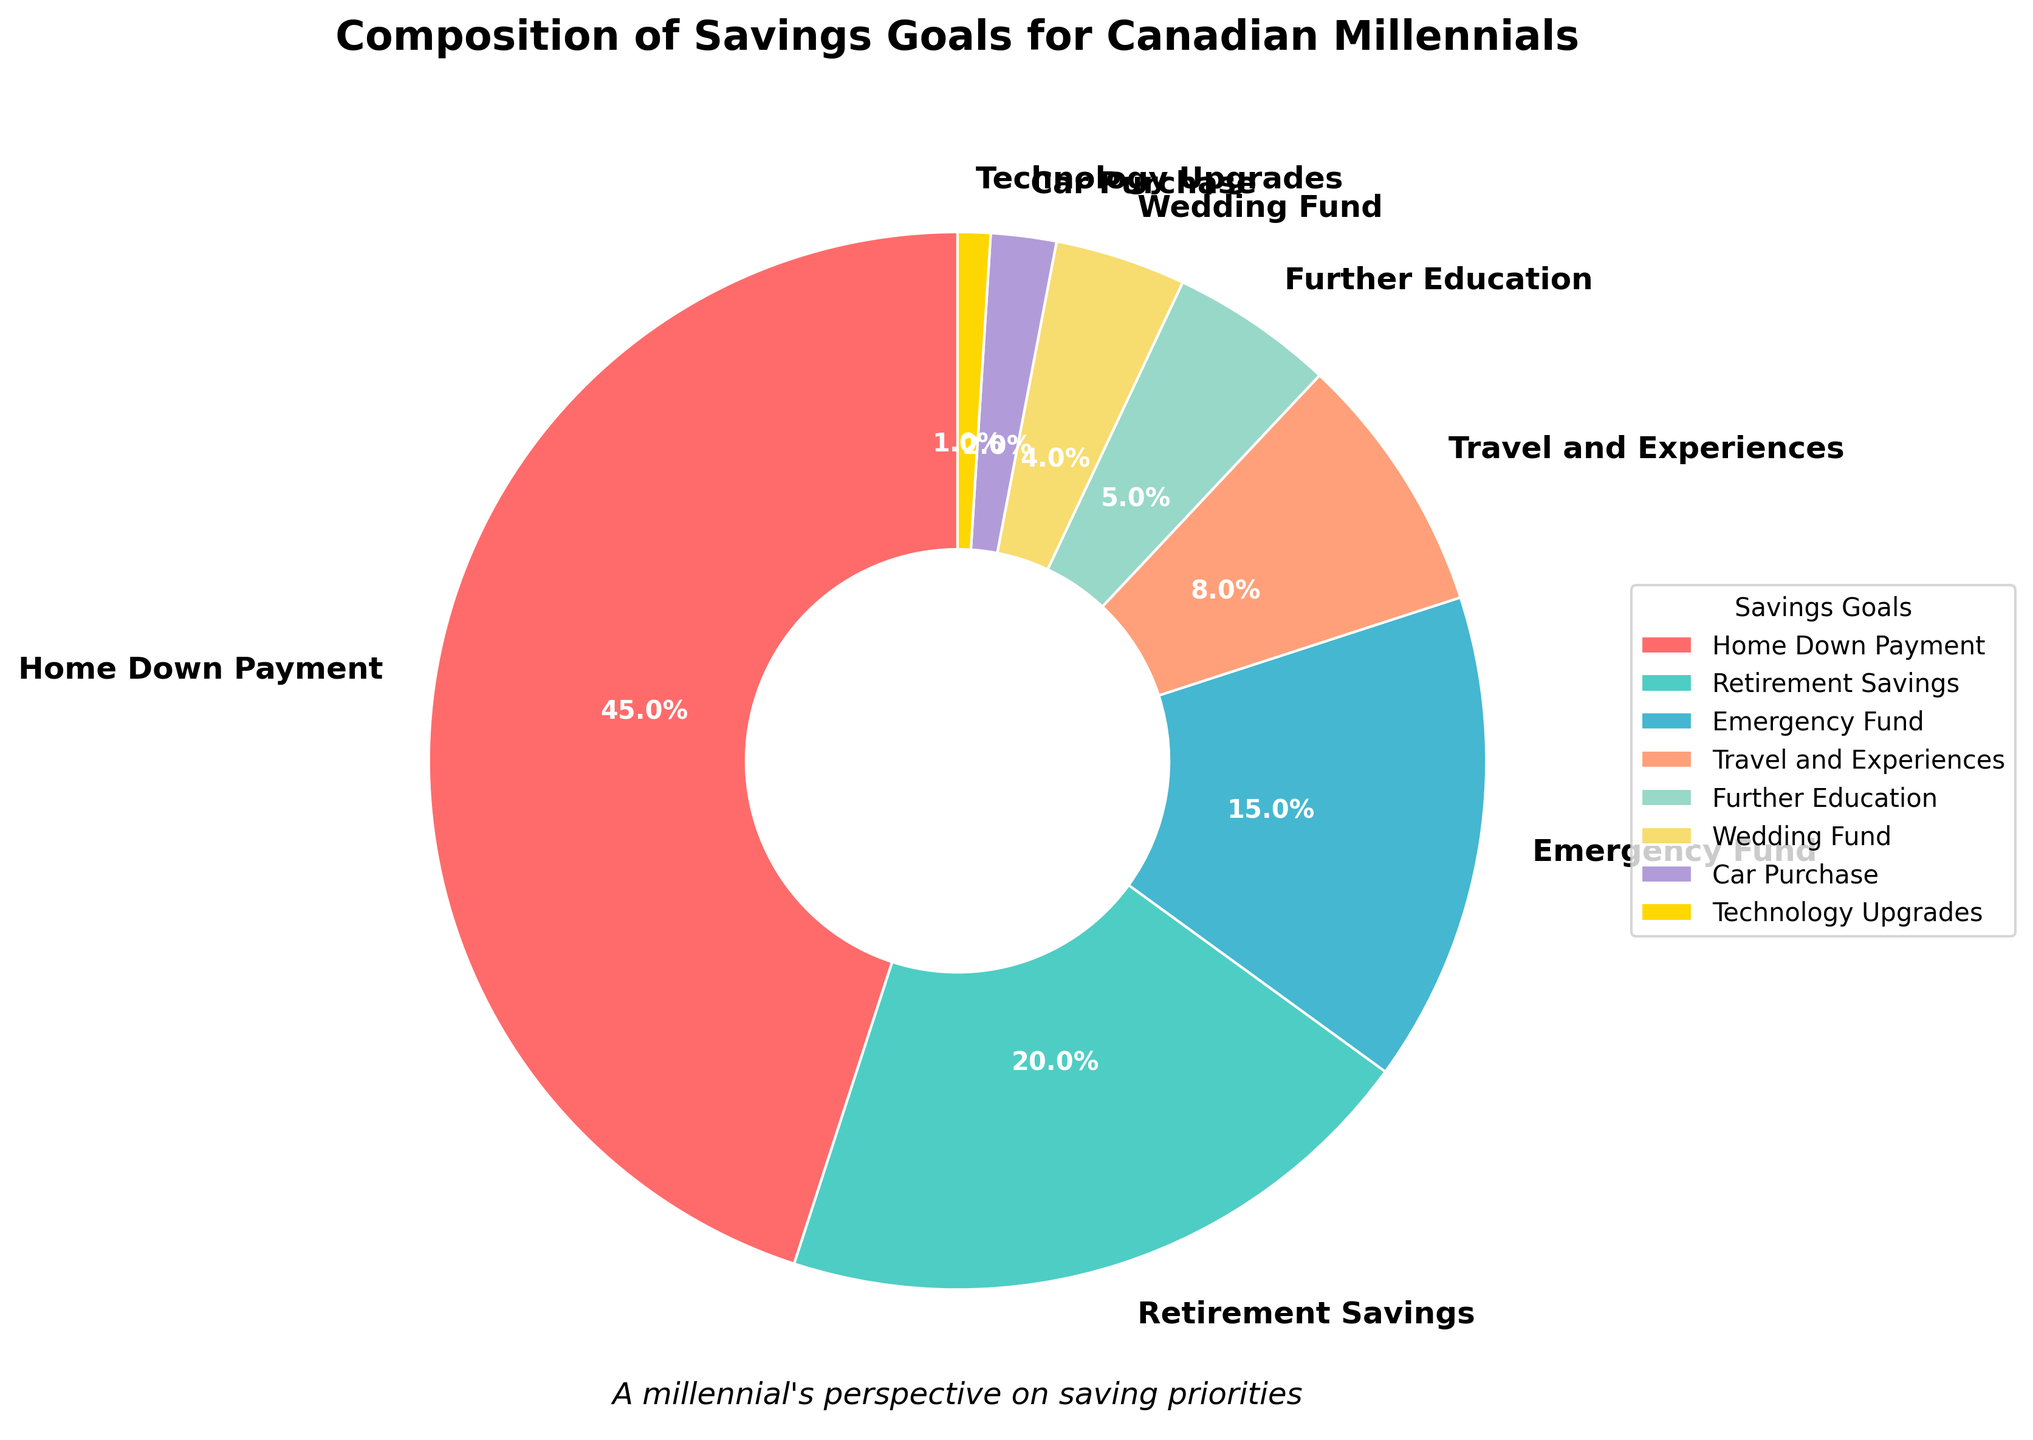what percentage of savings goals are allocated to home down payment and retirement savings combined? To find the combined percentage allocated to home down payment and retirement savings, add the percentages for both categories: 45% (home down payment) + 20% (retirement savings) = 65%
Answer: 65% which is greater, the percentage allocated to emergency fund or wedding fund? Compare the percentages for emergency fund (15%) and wedding fund (4%). Since 15% is greater than 4%, the emergency fund has a higher percentage.
Answer: emergency fund what is the difference between the percentages for travel and experiences and car purchase? Find the difference by subtracting the percentage of car purchase (2%) from the percentage of travel and experiences (8%): 8% - 2% = 6%
Answer: 6% which category has the smallest percentage allocation? Look at the percentage values for all categories. The smallest percentage is for technology upgrades at 1%.
Answer: technology upgrades what is the total percentage of savings goals allocated to travel and experiences, further education, and wedding fund? Add the percentages for travel and experiences (8%), further education (5%), and wedding fund (4%): 8% + 5% + 4% = 17%
Answer: 17% what color is used to represent the emergency fund category in the pie chart? Identify the color associated with the emergency fund category on the pie chart. The color used for the emergency fund is light blue.
Answer: light blue how many categories have a percentage allocation of 5% or less? Count the categories with percentages of 5% or less: further education (5%), wedding fund (4%), car purchase (2%), and technology upgrades (1%). There are 4 such categories.
Answer: 4 if you combine retirement savings and emergency funds, what proportion of the total does this represent? Find the combined percentage of retirement savings (20%) and emergency funds (15%), which is 20% + 15% = 35%. Since the total is 100%, the proportion is 35%.
Answer: 35% which category has a larger percentage, travel and experiences or further education? Compare the percentages for both categories: travel and experiences (8%) and further education (5%). Travel and experiences have a larger percentage.
Answer: travel and experiences 